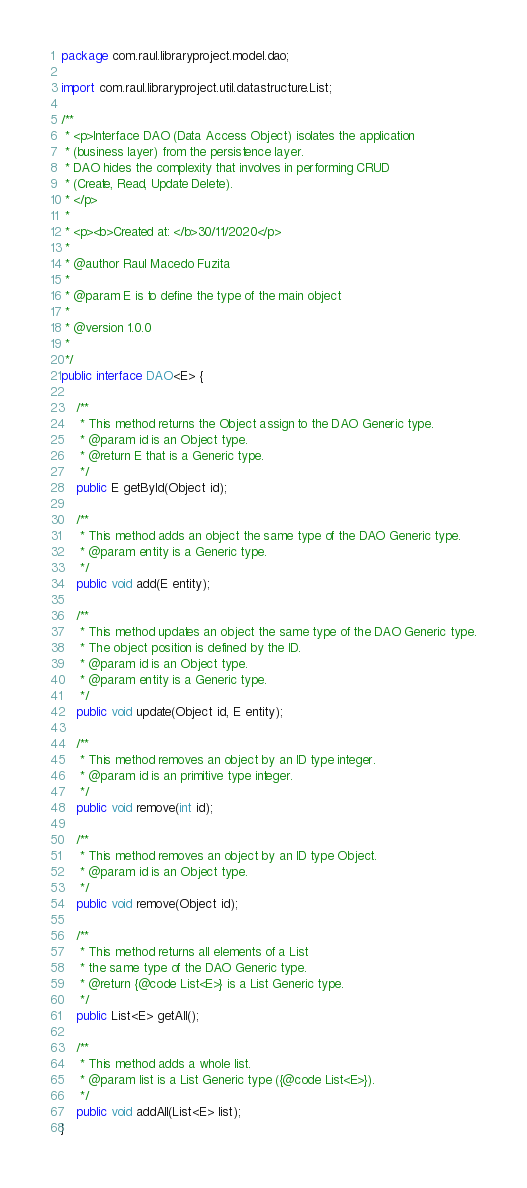<code> <loc_0><loc_0><loc_500><loc_500><_Java_>package com.raul.libraryproject.model.dao;

import com.raul.libraryproject.util.datastructure.List;

/**
 * <p>Interface DAO (Data Access Object) isolates the application 
 * (business layer) from the persistence layer.
 * DAO hides the complexity that involves in performing CRUD
 * (Create, Read, Update Delete).
 * </p>
 * 
 * <p><b>Created at: </b>30/11/2020</p>
 * 
 * @author Raul Macedo Fuzita
 * 
 * @param E is to define the type of the main object
 * 
 * @version 1.0.0
 *
 */
public interface DAO<E> {

	/**
	 * This method returns the Object assign to the DAO Generic type.
	 * @param id is an Object type.
	 * @return E that is a Generic type.
	 */
	public E getById(Object id);
	
	/**
	 * This method adds an object the same type of the DAO Generic type.
	 * @param entity is a Generic type.
	 */
	public void add(E entity);
	
	/**
	 * This method updates an object the same type of the DAO Generic type.
	 * The object position is defined by the ID.
	 * @param id is an Object type.
	 * @param entity is a Generic type.
	 */
	public void update(Object id, E entity);
	
	/**
	 * This method removes an object by an ID type integer.
	 * @param id is an primitive type integer.
	 */
	public void remove(int id);
	
	/**
	 * This method removes an object by an ID type Object.
	 * @param id is an Object type.
	 */
	public void remove(Object id);
	
	/**
	 * This method returns all elements of a List 
	 * the same type of the DAO Generic type.
	 * @return {@code List<E>} is a List Generic type.
	 */
	public List<E> getAll();
	
	/**
	 * This method adds a whole list.
	 * @param list is a List Generic type ({@code List<E>}).
	 */
	public void addAll(List<E> list);
}
</code> 